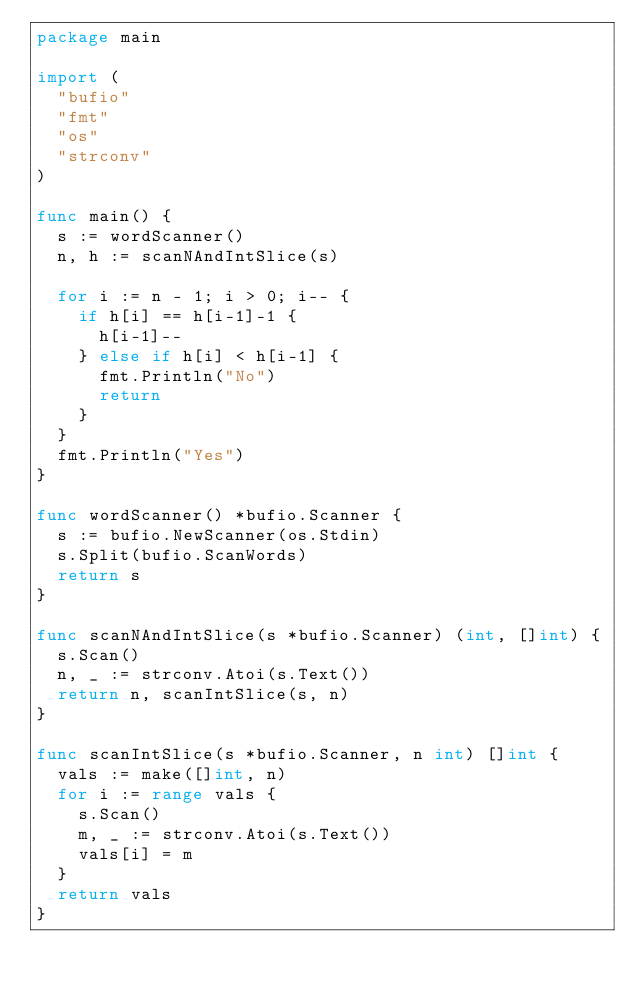Convert code to text. <code><loc_0><loc_0><loc_500><loc_500><_Go_>package main

import (
	"bufio"
	"fmt"
	"os"
	"strconv"
)

func main() {
	s := wordScanner()
	n, h := scanNAndIntSlice(s)

	for i := n - 1; i > 0; i-- {
		if h[i] == h[i-1]-1 {
			h[i-1]--
		} else if h[i] < h[i-1] {
			fmt.Println("No")
			return
		}
	}
	fmt.Println("Yes")
}

func wordScanner() *bufio.Scanner {
	s := bufio.NewScanner(os.Stdin)
	s.Split(bufio.ScanWords)
	return s
}

func scanNAndIntSlice(s *bufio.Scanner) (int, []int) {
	s.Scan()
	n, _ := strconv.Atoi(s.Text())
	return n, scanIntSlice(s, n)
}

func scanIntSlice(s *bufio.Scanner, n int) []int {
	vals := make([]int, n)
	for i := range vals {
		s.Scan()
		m, _ := strconv.Atoi(s.Text())
		vals[i] = m
	}
	return vals
}
</code> 